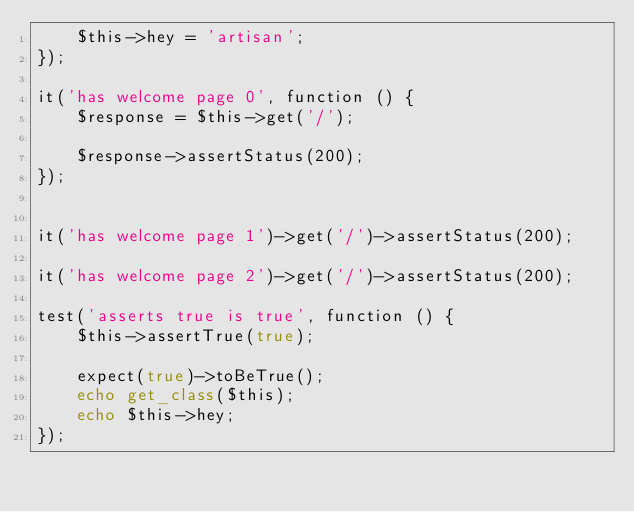<code> <loc_0><loc_0><loc_500><loc_500><_PHP_>    $this->hey = 'artisan';
});

it('has welcome page 0', function () {
    $response = $this->get('/');

    $response->assertStatus(200);
});


it('has welcome page 1')->get('/')->assertStatus(200);

it('has welcome page 2')->get('/')->assertStatus(200);

test('asserts true is true', function () {
    $this->assertTrue(true);

    expect(true)->toBeTrue();
    echo get_class($this); 
    echo $this->hey;
});</code> 